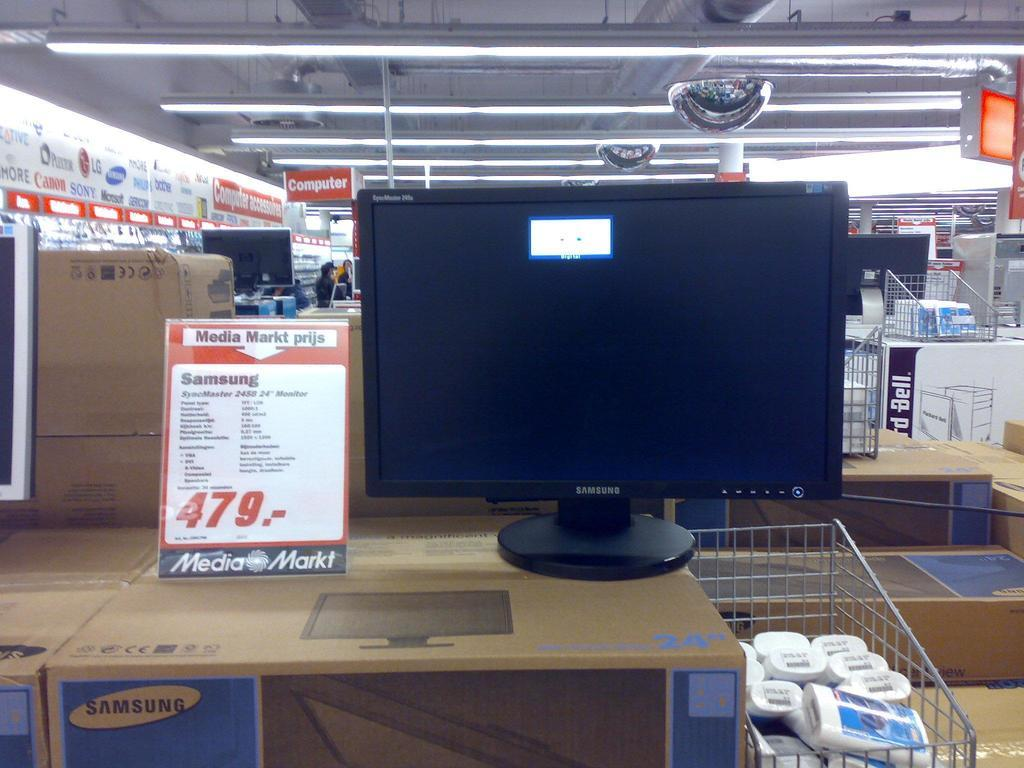<image>
Share a concise interpretation of the image provided. Samsung SyncMaster 479 is shown on the price tag next to the monitor. 